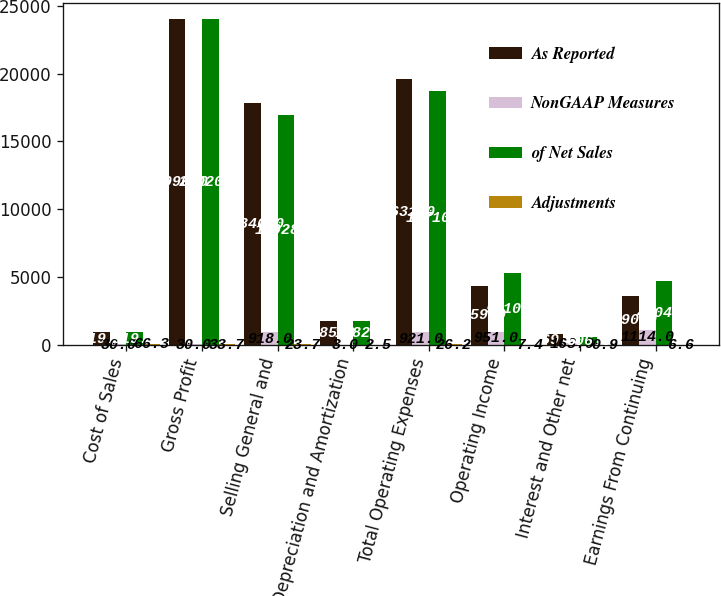Convert chart. <chart><loc_0><loc_0><loc_500><loc_500><stacked_bar_chart><ecel><fcel>Cost of Sales<fcel>Gross Profit<fcel>Selling General and<fcel>Depreciation and Amortization<fcel>Total Operating Expenses<fcel>Operating Income<fcel>Interest and Other net<fcel>Earnings From Continuing<nl><fcel>As Reported<fcel>919.5<fcel>23990<fcel>17846<fcel>1785<fcel>19631<fcel>4359<fcel>769<fcel>3590<nl><fcel>NonGAAP Measures<fcel>30<fcel>30<fcel>918<fcel>3<fcel>921<fcel>951<fcel>163<fcel>1114<nl><fcel>of Net Sales<fcel>919.5<fcel>24020<fcel>16928<fcel>1782<fcel>18710<fcel>5310<fcel>606<fcel>4704<nl><fcel>Adjustments<fcel>66.3<fcel>33.7<fcel>23.7<fcel>2.5<fcel>26.2<fcel>7.4<fcel>0.9<fcel>6.6<nl></chart> 